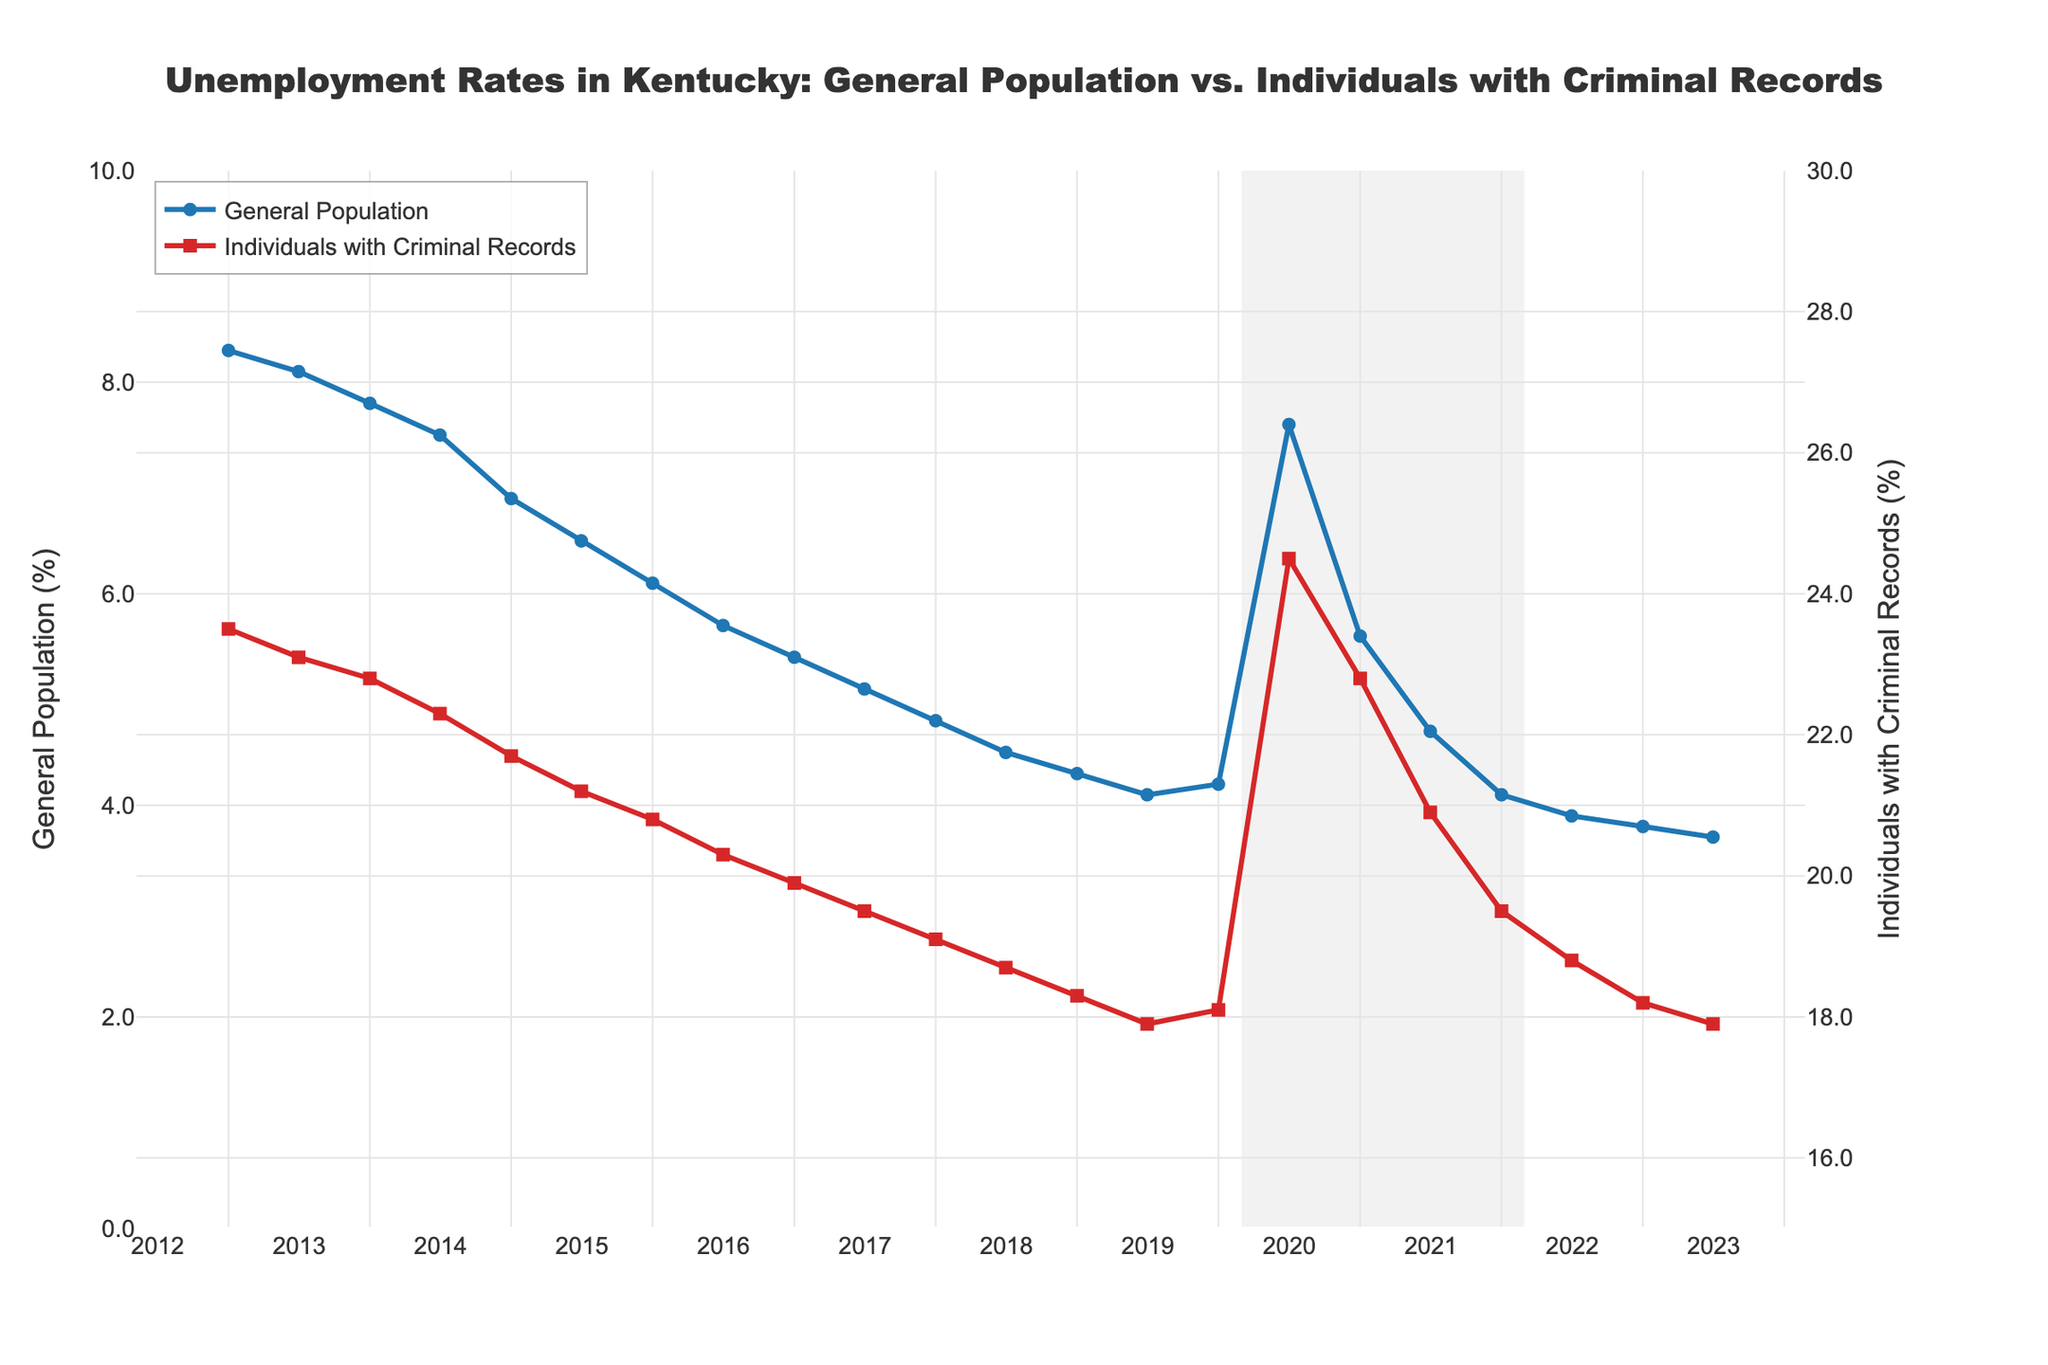What period is highlighted in gray on the plot? The gray highlighted area represents the time period from March 2020 to March 2022, which corresponds to the COVID-19 pandemic. This is indicated by the annotation labeled "COVID-19 Pandemic."
Answer: March 2020 to March 2022 How did the unemployment rate for individuals with criminal records change from January 2020 to July 2020? The unemployment rate for individuals with criminal records increased from 18.1% in January 2020 to 24.5% in July 2020.
Answer: Increased from 18.1% to 24.5% What is the difference in unemployment rates between the general population and individuals with criminal records in January 2013? In January 2013, the unemployment rate for the general population was 8.3%, and for individuals with criminal records, it was 23.5%. The difference is 23.5% - 8.3% = 15.2%.
Answer: 15.2% Which group experienced a more significant relative increase in unemployment rates during the COVID-19 pandemic period? To find the relative increase, we compare the percentage changes for both groups. For the general population: [(7.6 - 4.2)/4.2]*100 ≈ 80.95%. For individuals with criminal records: [(24.5 - 18.1)/18.1]*100 ≈ 35.36%. The general population experienced a more significant relative increase.
Answer: General population What is the visual trend for the unemployment rate of the general population from 2013 to 2023? The unemployment rate for the general population shows a general downward trend from 2013 to 2023. It starts high, decreases steadily until 2020, spikes during the pandemic, and then continues to decrease again.
Answer: Downward trend Which year had the lowest unemployment rate for individuals with criminal records, and what was the rate? The lowest unemployment rate for individuals with criminal records was in July 2023, with a rate of 17.9%.
Answer: July 2023, 17.9% Compare the unemployment rates for the general population between January 2013 and January 2023. In January 2013, the unemployment rate for the general population was 8.3%, and in January 2023, it was 3.8%. The rate decreased by 8.3% - 3.8% = 4.5%.
Answer: Decreased by 4.5% How does the unemployment rate trend during the pandemic compare between the general population and individuals with criminal records? During the pandemic (March 2020 - March 2022), both groups saw spikes in unemployment rates. However, the general population's unemployment rate increased significantly from 4.2% to 7.6%, whereas individuals with criminal records saw an increase from 18.1% to 24.5%. Both groups experienced a peak during the pandemic but the general population had a more significant relative increase.
Answer: Both groups spiked, but the general population had a more significant relative increase By how much did the unemployment rate for individuals with criminal records decrease from its peak during the pandemic to July 2023? The peak unemployment rate for individuals with criminal records during the pandemic was 24.5% in July 2020. By July 2023, it decreased to 17.9%. The decrease is 24.5% - 17.9% = 6.6%.
Answer: 6.6% decrease What is the general unemployment rate trend before and after the pandemic, and how does it differ for individuals with criminal records? Before the pandemic, both groups experienced a steady decline in unemployment rates. During the pandemic, there was a significant spike, followed by a decline post-pandemic. The general trend resumed downward after the pandemic for both groups, but individuals with criminal records maintained a consistently higher unemployment rate throughout.
Answer: Both groups: steady decline before and after with a spike during the pandemic; criminal records: consistently higher rate 